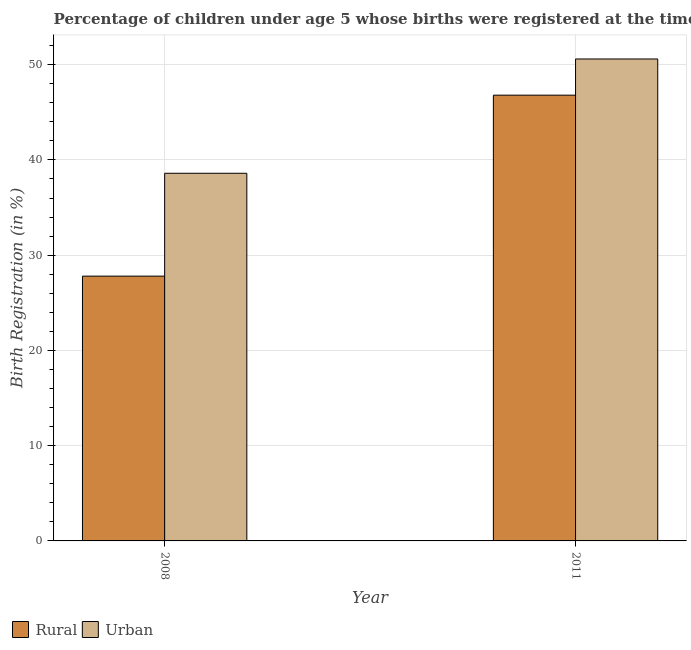How many different coloured bars are there?
Make the answer very short. 2. How many groups of bars are there?
Ensure brevity in your answer.  2. Are the number of bars per tick equal to the number of legend labels?
Keep it short and to the point. Yes. How many bars are there on the 1st tick from the left?
Offer a very short reply. 2. In how many cases, is the number of bars for a given year not equal to the number of legend labels?
Your response must be concise. 0. What is the urban birth registration in 2011?
Keep it short and to the point. 50.6. Across all years, what is the maximum rural birth registration?
Ensure brevity in your answer.  46.8. Across all years, what is the minimum rural birth registration?
Offer a terse response. 27.8. In which year was the rural birth registration maximum?
Your answer should be very brief. 2011. In which year was the urban birth registration minimum?
Ensure brevity in your answer.  2008. What is the total urban birth registration in the graph?
Ensure brevity in your answer.  89.2. What is the difference between the urban birth registration in 2008 and that in 2011?
Your answer should be compact. -12. What is the difference between the urban birth registration in 2011 and the rural birth registration in 2008?
Provide a short and direct response. 12. What is the average urban birth registration per year?
Ensure brevity in your answer.  44.6. In the year 2011, what is the difference between the urban birth registration and rural birth registration?
Your answer should be compact. 0. In how many years, is the rural birth registration greater than 26 %?
Ensure brevity in your answer.  2. What is the ratio of the rural birth registration in 2008 to that in 2011?
Ensure brevity in your answer.  0.59. Is the urban birth registration in 2008 less than that in 2011?
Your answer should be compact. Yes. In how many years, is the rural birth registration greater than the average rural birth registration taken over all years?
Provide a short and direct response. 1. What does the 2nd bar from the left in 2011 represents?
Your answer should be very brief. Urban. What does the 2nd bar from the right in 2011 represents?
Provide a short and direct response. Rural. How many bars are there?
Keep it short and to the point. 4. Are all the bars in the graph horizontal?
Ensure brevity in your answer.  No. Are the values on the major ticks of Y-axis written in scientific E-notation?
Offer a terse response. No. Where does the legend appear in the graph?
Make the answer very short. Bottom left. How are the legend labels stacked?
Offer a terse response. Horizontal. What is the title of the graph?
Your answer should be compact. Percentage of children under age 5 whose births were registered at the time of the survey in Mozambique. Does "Food and tobacco" appear as one of the legend labels in the graph?
Offer a very short reply. No. What is the label or title of the Y-axis?
Ensure brevity in your answer.  Birth Registration (in %). What is the Birth Registration (in %) of Rural in 2008?
Make the answer very short. 27.8. What is the Birth Registration (in %) in Urban in 2008?
Make the answer very short. 38.6. What is the Birth Registration (in %) of Rural in 2011?
Offer a very short reply. 46.8. What is the Birth Registration (in %) of Urban in 2011?
Your answer should be very brief. 50.6. Across all years, what is the maximum Birth Registration (in %) in Rural?
Provide a short and direct response. 46.8. Across all years, what is the maximum Birth Registration (in %) of Urban?
Your response must be concise. 50.6. Across all years, what is the minimum Birth Registration (in %) in Rural?
Give a very brief answer. 27.8. Across all years, what is the minimum Birth Registration (in %) of Urban?
Provide a short and direct response. 38.6. What is the total Birth Registration (in %) in Rural in the graph?
Your answer should be very brief. 74.6. What is the total Birth Registration (in %) of Urban in the graph?
Your answer should be very brief. 89.2. What is the difference between the Birth Registration (in %) in Urban in 2008 and that in 2011?
Provide a short and direct response. -12. What is the difference between the Birth Registration (in %) of Rural in 2008 and the Birth Registration (in %) of Urban in 2011?
Offer a terse response. -22.8. What is the average Birth Registration (in %) in Rural per year?
Give a very brief answer. 37.3. What is the average Birth Registration (in %) of Urban per year?
Ensure brevity in your answer.  44.6. In the year 2008, what is the difference between the Birth Registration (in %) in Rural and Birth Registration (in %) in Urban?
Give a very brief answer. -10.8. In the year 2011, what is the difference between the Birth Registration (in %) of Rural and Birth Registration (in %) of Urban?
Give a very brief answer. -3.8. What is the ratio of the Birth Registration (in %) of Rural in 2008 to that in 2011?
Provide a succinct answer. 0.59. What is the ratio of the Birth Registration (in %) of Urban in 2008 to that in 2011?
Provide a short and direct response. 0.76. What is the difference between the highest and the second highest Birth Registration (in %) in Urban?
Your answer should be very brief. 12. 